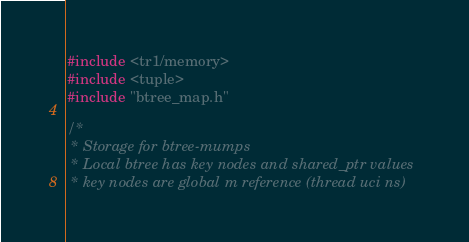<code> <loc_0><loc_0><loc_500><loc_500><_C_>#include <tr1/memory>
#include <tuple>
#include "btree_map.h"

/*
 * Storage for btree-mumps
 * Local btree has key nodes and shared_ptr values
 * key nodes are global m reference (thread uci ns)</code> 